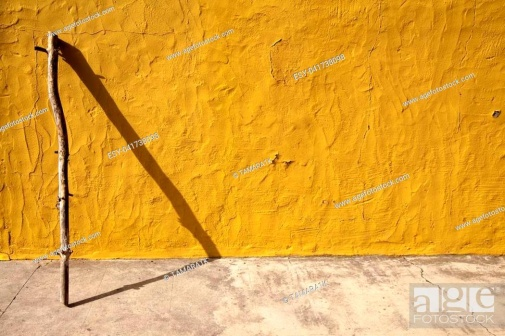What emotions does this image evoke for you? The image evokes a sense of calm and stillness. The simplicity of the scene, featuring just a stick leaning against a vibrant yellow wall, radiates tranquility. The play of shadows and the rich contrast in colors add a touch of intrigue and warmth. This combination of elements produces a soothing and contemplative atmosphere. 